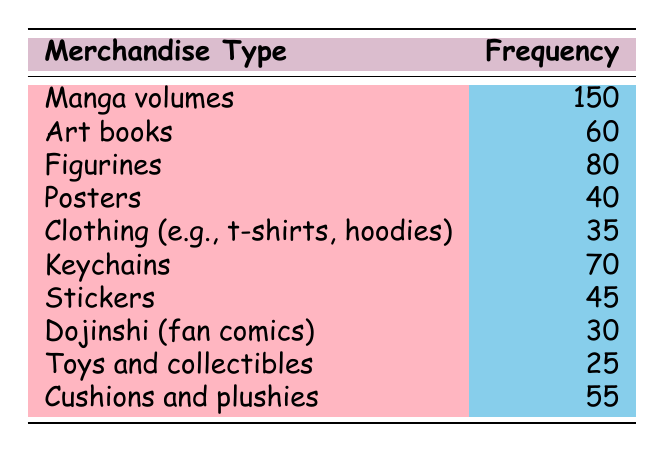What is the most purchased type of comic merchandise? According to the table, the merchandise type with the highest frequency is "Manga volumes," with a frequency of 150, making it the most purchased item.
Answer: Manga volumes How many more figurines than dojinschi were purchased? The frequency for "Figurines" is 80, and for "Dojinshi," it is 30. The difference is calculated by subtracting the latter from the former: 80 - 30 = 50.
Answer: 50 Is there a higher frequency of clothing purchases than poster purchases? From the table, the frequency of "Clothing (e.g., t-shirts, hoodies)" is 35, and "Posters" is 40. Since 35 is less than 40, the answer is no.
Answer: No What is the total frequency of keychains and stickers purchased? The frequency for "Keychains" is 70, and for "Stickers" is 45. To find the total, we add both frequencies together: 70 + 45 = 115.
Answer: 115 How many types of merchandise had a frequency of 50 or more? The items with a frequency of 50 or more include "Manga volumes" (150), "Figurines" (80), "Keychains" (70), "Cushions and plushies" (55), and "Art books" (60). This counts to 5 types in total.
Answer: 5 What is the average frequency of the merchandise types listed? To find the average frequency, sum the frequencies: 150 + 60 + 80 + 40 + 35 + 70 + 45 + 30 + 25 + 55 = 610. There are 10 types of merchandise, so to find the average, we divide the total frequency by the number of types: 610 / 10 = 61.
Answer: 61 Was the frequency of stickers lower than that of clothing? The frequency for "Stickers" is 45, and for "Clothing" is 35. Since 45 is greater than 35, the answer is no.
Answer: No Which type of merchandise had the lowest frequency? According to the table, "Toys and collectibles" has the lowest frequency with a count of 25.
Answer: Toys and collectibles 